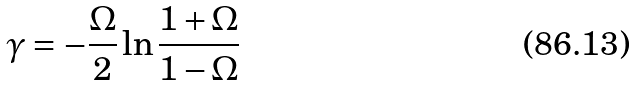<formula> <loc_0><loc_0><loc_500><loc_500>\gamma = - \frac { \Omega } { 2 } \ln \frac { 1 + \Omega } { 1 - \Omega }</formula> 